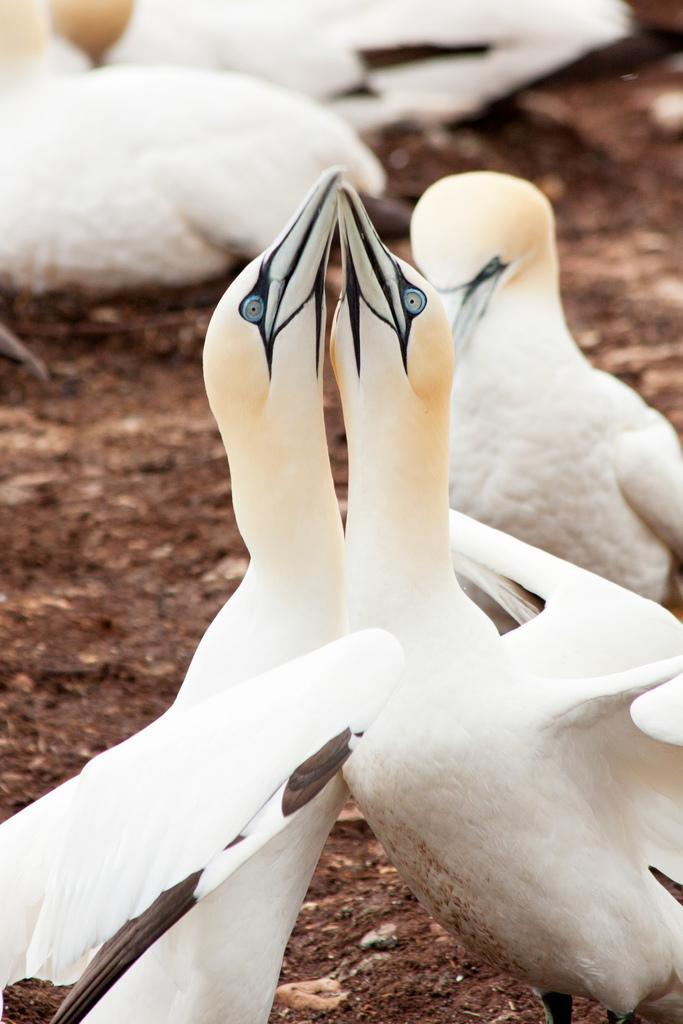How would you summarize this image in a sentence or two? We can see birds on the surface. 